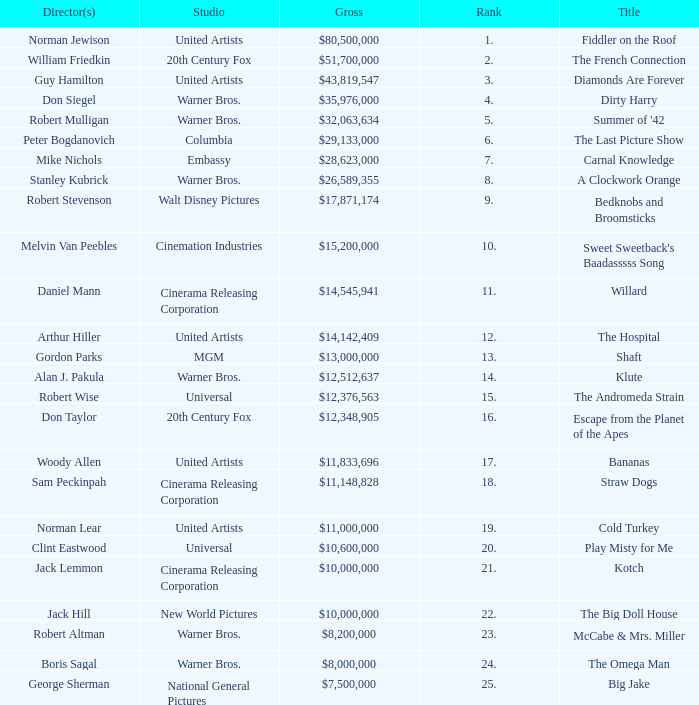What rank is the title with a gross of $26,589,355? 8.0. 